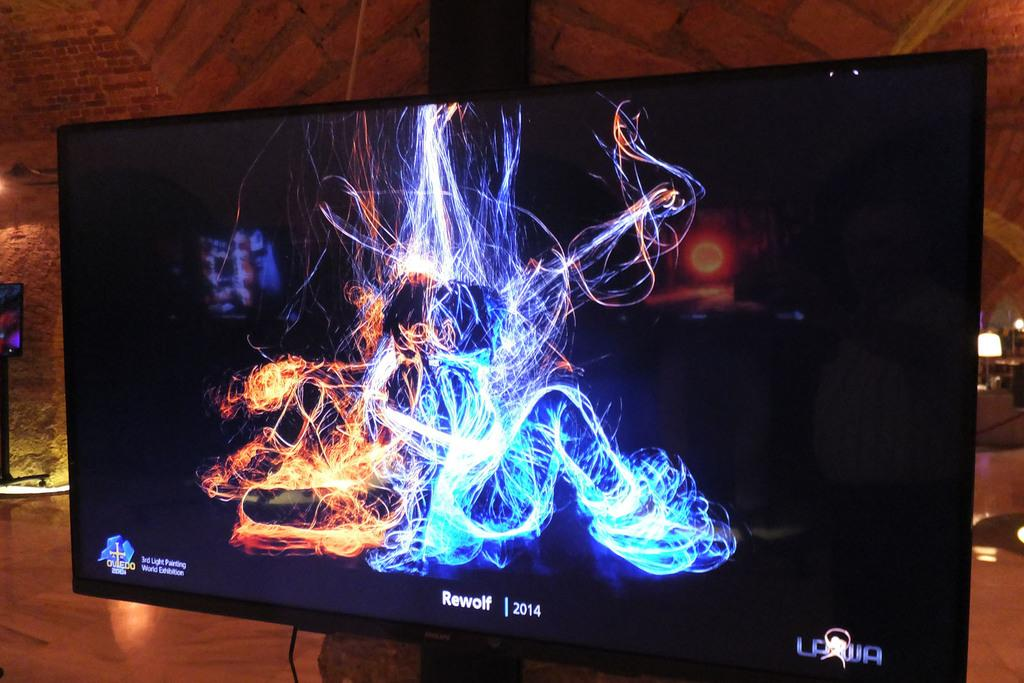Provide a one-sentence caption for the provided image. A monitor displays a colorful image along with the text "Rewolf 2014". 